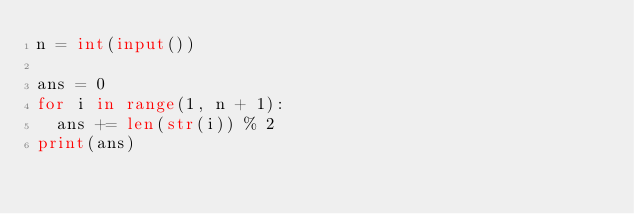Convert code to text. <code><loc_0><loc_0><loc_500><loc_500><_Python_>n = int(input())

ans = 0
for i in range(1, n + 1):
  ans += len(str(i)) % 2
print(ans)</code> 